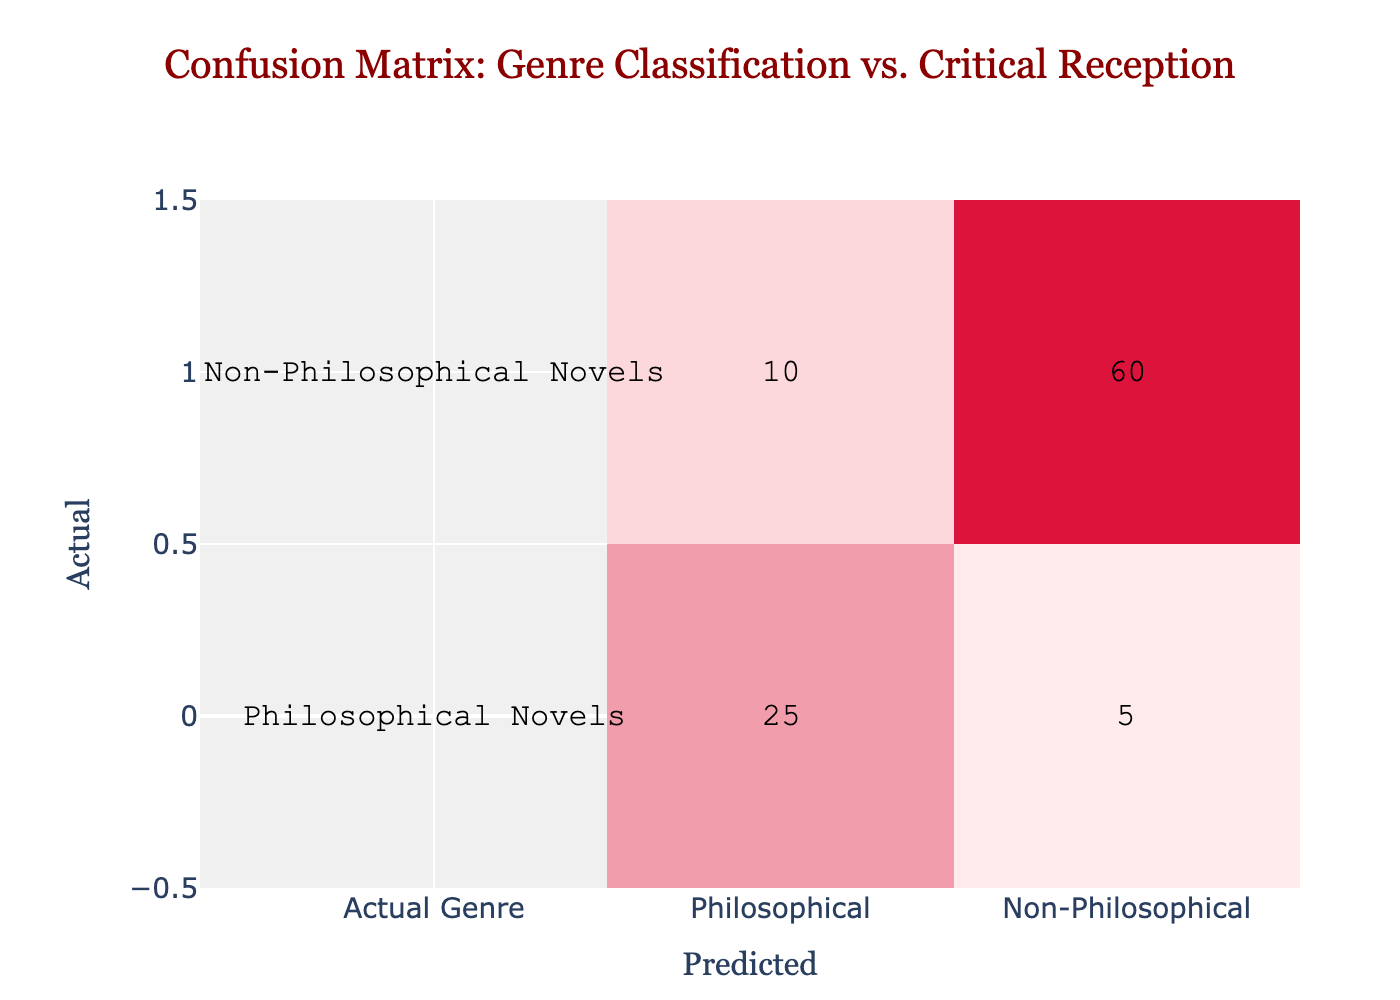What is the number of correctly predicted philosophical novels? The correctly predicted philosophical novels are in the cell corresponding to actual philosophical novels and predicted philosophical novels. This value is 25.
Answer: 25 How many non-philosophical novels were incorrectly classified as philosophical? The incorrectly classified non-philosophical novels are in the cell corresponding to actual non-philosophical novels and predicted philosophical novels. The value is 10.
Answer: 10 What is the total number of philosophical novels in the dataset? To find the total number of philosophical novels, we sum the values of the row corresponding to actual philosophical novels: 25 (correctly predicted) + 5 (incorrectly predicted) = 30.
Answer: 30 What percentage of the classified non-philosophical novels were correctly classified? To calculate the percentage of correctly classified non-philosophical novels, we take the value of correctly classified non-philosophical novels (60), divide it by the total number of actual non-philosophical novels (70), and multiply by 100: (60 / 70) * 100 = 85.71%.
Answer: 85.71% Is it true that more philosophical novels were incorrectly classified than non-philosophical novels? The incorrectly classified philosophical novels are 5, while the incorrectly classified non-philosophical novels are 10. Since 10 is greater than 5, the statement is true.
Answer: Yes What is the total number of novels in the dataset? The total number of novels is the sum of all the values in the confusion matrix: 25 (correct philosophical) + 5 (incorrect philosophical) + 10 (incorrect non-philosophical) + 60 (correct non-philosophical) = 100.
Answer: 100 What is the difference between the correctly classified philosophical and non-philosophical novels? The difference can be calculated by subtracting the correctly classified non-philosophical novels (60) from the correctly classified philosophical novels (25): 25 - 60 = -35. This means there are 35 fewer correctly classified philosophical novels.
Answer: -35 How many total novels are misclassified in the dataset? To find the total number of misclassified novels, we sum the two cells with misclassifications: 5 (incorrectly predicted philosophical) + 10 (incorrectly predicted non-philosophical) = 15.
Answer: 15 Was the classification of philosophical novels more successful than that of non-philosophical novels? To assess this, we compare the accuracy of both genres. The accuracy for philosophical novels is 25 out of 30 (correctly classified) = 83.33%, and for non-philosophical it is 60 out of 70 = 85.71%. Since 85.71% is higher than 83.33%, the classification of philosophical novels was less successful.
Answer: No 